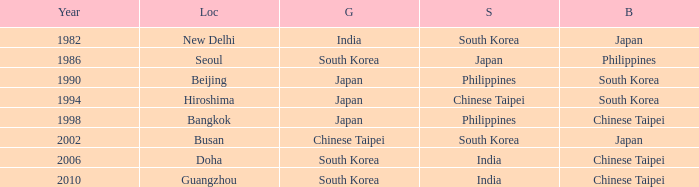How many years has Japan won silver? 1986.0. 